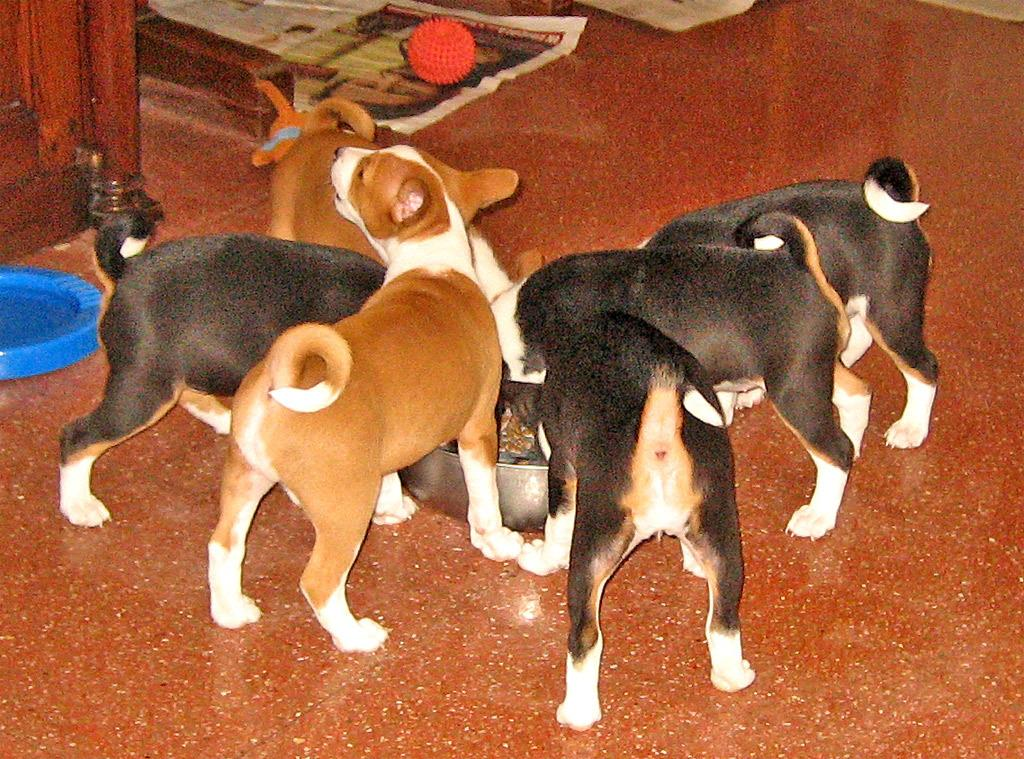What animals are present in the image? There are dogs in the image. What are the dogs doing in the image? The dogs are eating something in a bowl. What else can be seen in the image besides the dogs? There are objects and a paper in the image. What type of toothpaste is the dog using in the image? There is no toothpaste present in the image; the dogs are eating something from a bowl. How many planes are visible in the image? There are no planes visible in the image. 